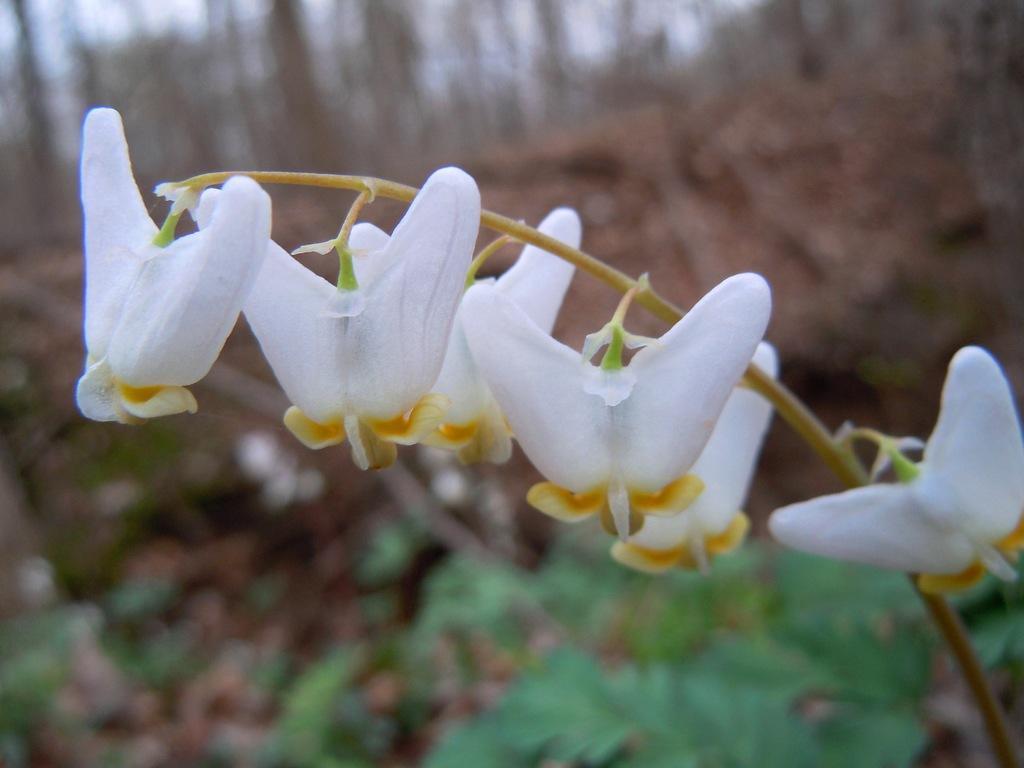Describe this image in one or two sentences. In the picture I can see white color flowers of a plant and the background of the image is blurred, where I can see trees. 